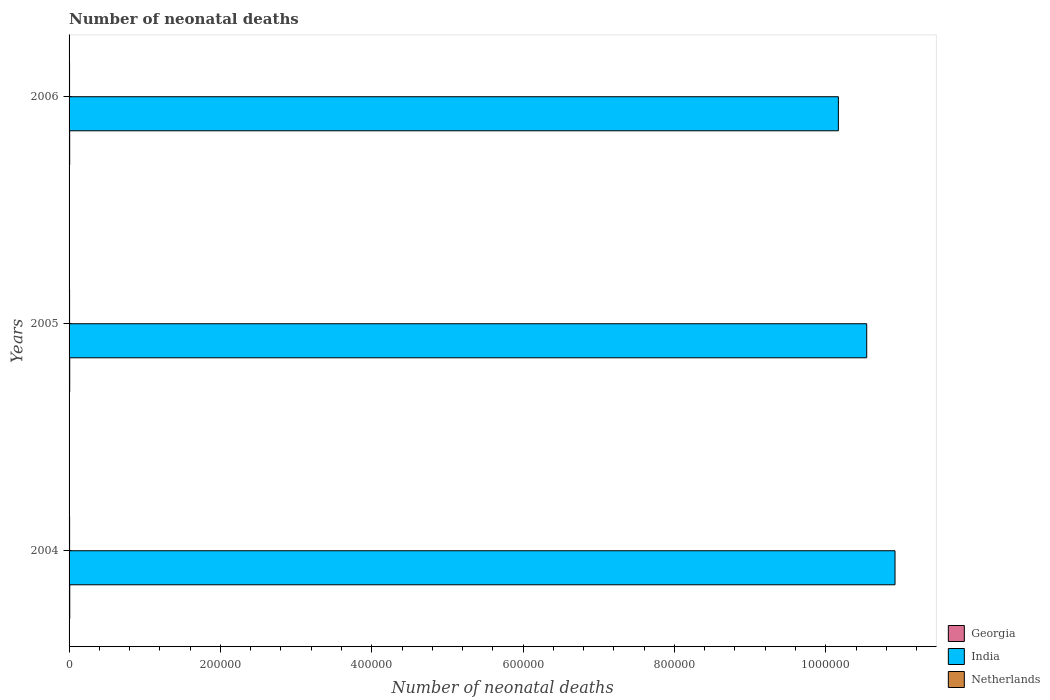How many different coloured bars are there?
Your answer should be very brief. 3. How many groups of bars are there?
Keep it short and to the point. 3. Are the number of bars per tick equal to the number of legend labels?
Keep it short and to the point. Yes. How many bars are there on the 2nd tick from the top?
Keep it short and to the point. 3. How many bars are there on the 3rd tick from the bottom?
Give a very brief answer. 3. What is the label of the 2nd group of bars from the top?
Your response must be concise. 2005. In how many cases, is the number of bars for a given year not equal to the number of legend labels?
Offer a very short reply. 0. What is the number of neonatal deaths in in India in 2004?
Your response must be concise. 1.09e+06. Across all years, what is the maximum number of neonatal deaths in in India?
Your response must be concise. 1.09e+06. Across all years, what is the minimum number of neonatal deaths in in Georgia?
Offer a terse response. 814. In which year was the number of neonatal deaths in in Netherlands maximum?
Offer a very short reply. 2004. What is the total number of neonatal deaths in in Netherlands in the graph?
Provide a short and direct response. 2058. What is the difference between the number of neonatal deaths in in Netherlands in 2004 and that in 2005?
Offer a very short reply. 23. What is the difference between the number of neonatal deaths in in India in 2006 and the number of neonatal deaths in in Georgia in 2005?
Provide a succinct answer. 1.02e+06. What is the average number of neonatal deaths in in India per year?
Provide a succinct answer. 1.05e+06. In the year 2005, what is the difference between the number of neonatal deaths in in India and number of neonatal deaths in in Georgia?
Offer a terse response. 1.05e+06. In how many years, is the number of neonatal deaths in in Georgia greater than 600000 ?
Your response must be concise. 0. What is the ratio of the number of neonatal deaths in in Georgia in 2004 to that in 2005?
Keep it short and to the point. 1.05. Is the number of neonatal deaths in in Georgia in 2004 less than that in 2006?
Your response must be concise. No. What is the difference between the highest and the second highest number of neonatal deaths in in Netherlands?
Your answer should be compact. 23. What is the difference between the highest and the lowest number of neonatal deaths in in Netherlands?
Your response must be concise. 58. In how many years, is the number of neonatal deaths in in Netherlands greater than the average number of neonatal deaths in in Netherlands taken over all years?
Your answer should be compact. 2. Is the sum of the number of neonatal deaths in in Netherlands in 2005 and 2006 greater than the maximum number of neonatal deaths in in India across all years?
Provide a succinct answer. No. What does the 2nd bar from the top in 2006 represents?
Offer a very short reply. India. What does the 2nd bar from the bottom in 2004 represents?
Your answer should be compact. India. How many bars are there?
Offer a very short reply. 9. Are all the bars in the graph horizontal?
Give a very brief answer. Yes. How many years are there in the graph?
Keep it short and to the point. 3. What is the difference between two consecutive major ticks on the X-axis?
Your answer should be compact. 2.00e+05. Are the values on the major ticks of X-axis written in scientific E-notation?
Your answer should be very brief. No. Where does the legend appear in the graph?
Offer a terse response. Bottom right. How are the legend labels stacked?
Your response must be concise. Vertical. What is the title of the graph?
Your response must be concise. Number of neonatal deaths. What is the label or title of the X-axis?
Ensure brevity in your answer.  Number of neonatal deaths. What is the label or title of the Y-axis?
Offer a very short reply. Years. What is the Number of neonatal deaths in Georgia in 2004?
Make the answer very short. 897. What is the Number of neonatal deaths of India in 2004?
Ensure brevity in your answer.  1.09e+06. What is the Number of neonatal deaths in Netherlands in 2004?
Your response must be concise. 713. What is the Number of neonatal deaths of Georgia in 2005?
Provide a short and direct response. 856. What is the Number of neonatal deaths in India in 2005?
Your answer should be compact. 1.05e+06. What is the Number of neonatal deaths in Netherlands in 2005?
Provide a short and direct response. 690. What is the Number of neonatal deaths of Georgia in 2006?
Keep it short and to the point. 814. What is the Number of neonatal deaths of India in 2006?
Give a very brief answer. 1.02e+06. What is the Number of neonatal deaths in Netherlands in 2006?
Offer a terse response. 655. Across all years, what is the maximum Number of neonatal deaths in Georgia?
Offer a very short reply. 897. Across all years, what is the maximum Number of neonatal deaths of India?
Ensure brevity in your answer.  1.09e+06. Across all years, what is the maximum Number of neonatal deaths of Netherlands?
Give a very brief answer. 713. Across all years, what is the minimum Number of neonatal deaths of Georgia?
Give a very brief answer. 814. Across all years, what is the minimum Number of neonatal deaths in India?
Offer a terse response. 1.02e+06. Across all years, what is the minimum Number of neonatal deaths of Netherlands?
Your response must be concise. 655. What is the total Number of neonatal deaths in Georgia in the graph?
Give a very brief answer. 2567. What is the total Number of neonatal deaths of India in the graph?
Offer a very short reply. 3.16e+06. What is the total Number of neonatal deaths of Netherlands in the graph?
Keep it short and to the point. 2058. What is the difference between the Number of neonatal deaths in Georgia in 2004 and that in 2005?
Ensure brevity in your answer.  41. What is the difference between the Number of neonatal deaths of India in 2004 and that in 2005?
Provide a short and direct response. 3.74e+04. What is the difference between the Number of neonatal deaths of Georgia in 2004 and that in 2006?
Provide a succinct answer. 83. What is the difference between the Number of neonatal deaths in India in 2004 and that in 2006?
Provide a short and direct response. 7.49e+04. What is the difference between the Number of neonatal deaths in Netherlands in 2004 and that in 2006?
Offer a terse response. 58. What is the difference between the Number of neonatal deaths in India in 2005 and that in 2006?
Your response must be concise. 3.75e+04. What is the difference between the Number of neonatal deaths in Georgia in 2004 and the Number of neonatal deaths in India in 2005?
Your answer should be compact. -1.05e+06. What is the difference between the Number of neonatal deaths in Georgia in 2004 and the Number of neonatal deaths in Netherlands in 2005?
Ensure brevity in your answer.  207. What is the difference between the Number of neonatal deaths of India in 2004 and the Number of neonatal deaths of Netherlands in 2005?
Make the answer very short. 1.09e+06. What is the difference between the Number of neonatal deaths in Georgia in 2004 and the Number of neonatal deaths in India in 2006?
Offer a very short reply. -1.02e+06. What is the difference between the Number of neonatal deaths of Georgia in 2004 and the Number of neonatal deaths of Netherlands in 2006?
Offer a very short reply. 242. What is the difference between the Number of neonatal deaths of India in 2004 and the Number of neonatal deaths of Netherlands in 2006?
Give a very brief answer. 1.09e+06. What is the difference between the Number of neonatal deaths of Georgia in 2005 and the Number of neonatal deaths of India in 2006?
Give a very brief answer. -1.02e+06. What is the difference between the Number of neonatal deaths of Georgia in 2005 and the Number of neonatal deaths of Netherlands in 2006?
Your answer should be compact. 201. What is the difference between the Number of neonatal deaths in India in 2005 and the Number of neonatal deaths in Netherlands in 2006?
Your answer should be compact. 1.05e+06. What is the average Number of neonatal deaths of Georgia per year?
Give a very brief answer. 855.67. What is the average Number of neonatal deaths of India per year?
Ensure brevity in your answer.  1.05e+06. What is the average Number of neonatal deaths in Netherlands per year?
Your answer should be very brief. 686. In the year 2004, what is the difference between the Number of neonatal deaths in Georgia and Number of neonatal deaths in India?
Your answer should be very brief. -1.09e+06. In the year 2004, what is the difference between the Number of neonatal deaths of Georgia and Number of neonatal deaths of Netherlands?
Your response must be concise. 184. In the year 2004, what is the difference between the Number of neonatal deaths of India and Number of neonatal deaths of Netherlands?
Ensure brevity in your answer.  1.09e+06. In the year 2005, what is the difference between the Number of neonatal deaths of Georgia and Number of neonatal deaths of India?
Provide a short and direct response. -1.05e+06. In the year 2005, what is the difference between the Number of neonatal deaths of Georgia and Number of neonatal deaths of Netherlands?
Your answer should be very brief. 166. In the year 2005, what is the difference between the Number of neonatal deaths of India and Number of neonatal deaths of Netherlands?
Give a very brief answer. 1.05e+06. In the year 2006, what is the difference between the Number of neonatal deaths of Georgia and Number of neonatal deaths of India?
Provide a succinct answer. -1.02e+06. In the year 2006, what is the difference between the Number of neonatal deaths in Georgia and Number of neonatal deaths in Netherlands?
Offer a terse response. 159. In the year 2006, what is the difference between the Number of neonatal deaths of India and Number of neonatal deaths of Netherlands?
Your response must be concise. 1.02e+06. What is the ratio of the Number of neonatal deaths of Georgia in 2004 to that in 2005?
Your answer should be very brief. 1.05. What is the ratio of the Number of neonatal deaths of India in 2004 to that in 2005?
Provide a succinct answer. 1.04. What is the ratio of the Number of neonatal deaths in Georgia in 2004 to that in 2006?
Keep it short and to the point. 1.1. What is the ratio of the Number of neonatal deaths in India in 2004 to that in 2006?
Make the answer very short. 1.07. What is the ratio of the Number of neonatal deaths in Netherlands in 2004 to that in 2006?
Provide a short and direct response. 1.09. What is the ratio of the Number of neonatal deaths in Georgia in 2005 to that in 2006?
Provide a succinct answer. 1.05. What is the ratio of the Number of neonatal deaths of India in 2005 to that in 2006?
Provide a short and direct response. 1.04. What is the ratio of the Number of neonatal deaths of Netherlands in 2005 to that in 2006?
Provide a short and direct response. 1.05. What is the difference between the highest and the second highest Number of neonatal deaths of India?
Provide a short and direct response. 3.74e+04. What is the difference between the highest and the lowest Number of neonatal deaths of India?
Ensure brevity in your answer.  7.49e+04. 